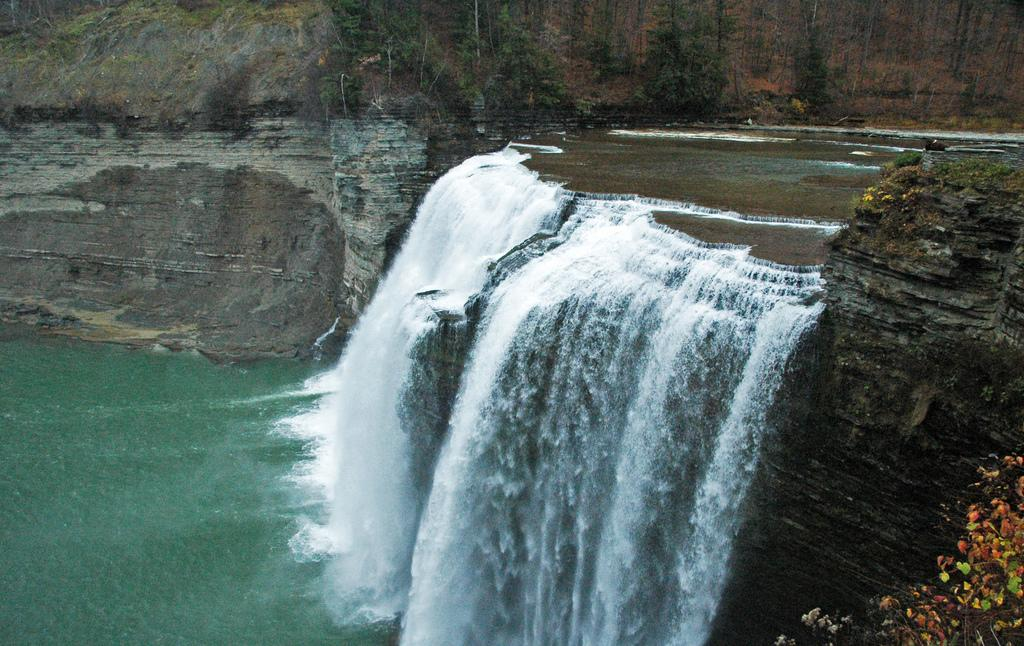What is the primary element visible in the image? There is water in the image. How is the water behaving in the image? The water is flowing in the image. What natural feature is located near the water? There is a rock near the water. What type of vegetation is present in the image? There are many trees in the image. Can you see any dinosaurs walking through the trees in the image? No, there are no dinosaurs present in the image. 